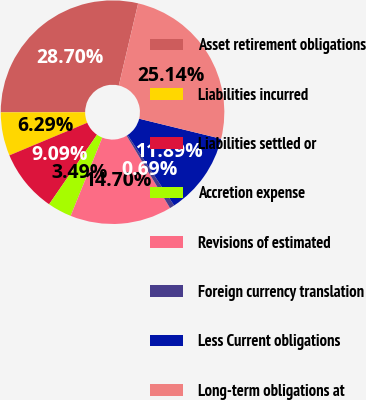Convert chart to OTSL. <chart><loc_0><loc_0><loc_500><loc_500><pie_chart><fcel>Asset retirement obligations<fcel>Liabilities incurred<fcel>Liabilities settled or<fcel>Accretion expense<fcel>Revisions of estimated<fcel>Foreign currency translation<fcel>Less Current obligations<fcel>Long-term obligations at<nl><fcel>28.7%<fcel>6.29%<fcel>9.09%<fcel>3.49%<fcel>14.7%<fcel>0.69%<fcel>11.89%<fcel>25.14%<nl></chart> 